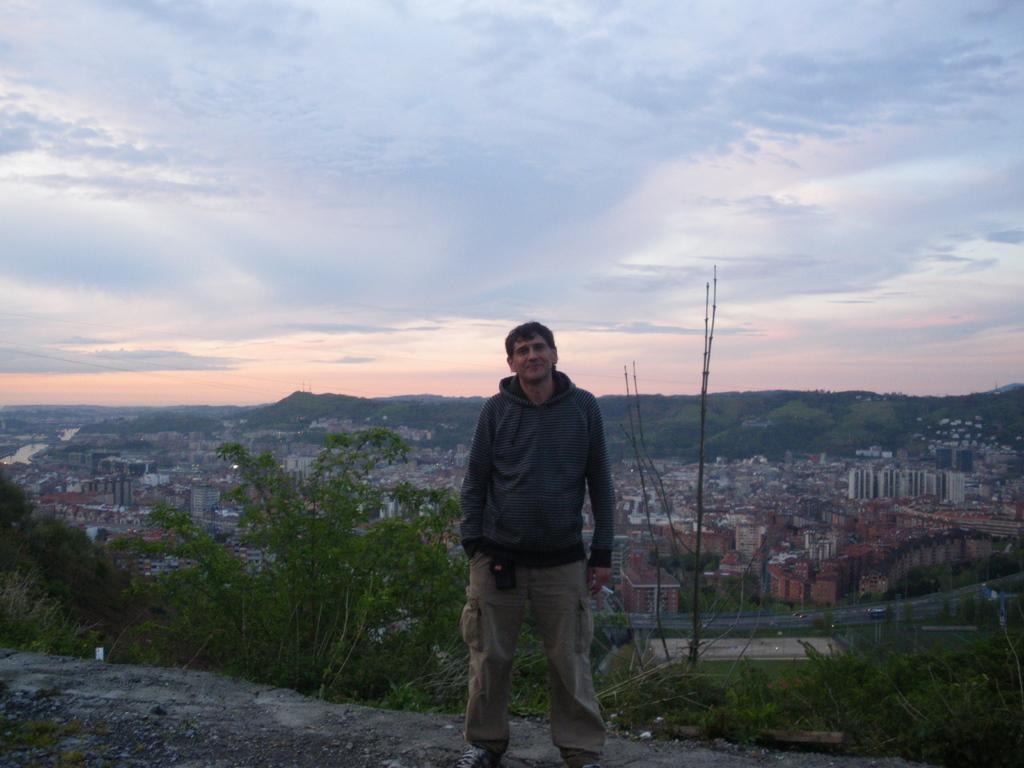What is the main subject of the image? There is a man standing in the image. Where is the man located in the image? The man is standing on a path. What can be seen behind the man in the image? There are trees and houses behind the man. What is visible in the sky in the image? The sky is visible in the image. How many hydrants can be seen on the path in the image? There are no hydrants visible on the path in the image. What type of dirt is present on the man's shoes in the image? There is no dirt visible on the man's shoes in the image. 